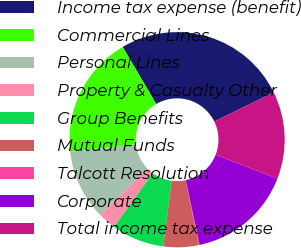Convert chart to OTSL. <chart><loc_0><loc_0><loc_500><loc_500><pie_chart><fcel>Income tax expense (benefit)<fcel>Commercial Lines<fcel>Personal Lines<fcel>Property & Casualty Other<fcel>Group Benefits<fcel>Mutual Funds<fcel>Talcott Resolution<fcel>Corporate<fcel>Total income tax expense<nl><fcel>26.19%<fcel>18.36%<fcel>10.53%<fcel>2.7%<fcel>7.92%<fcel>5.31%<fcel>0.09%<fcel>15.75%<fcel>13.14%<nl></chart> 